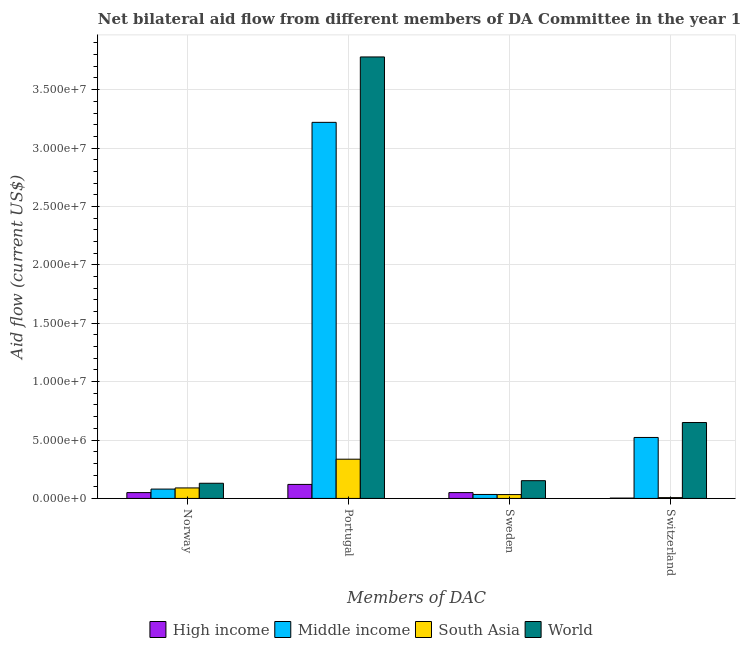How many different coloured bars are there?
Your answer should be very brief. 4. Are the number of bars per tick equal to the number of legend labels?
Your answer should be very brief. Yes. How many bars are there on the 3rd tick from the right?
Your response must be concise. 4. What is the amount of aid given by sweden in Middle income?
Offer a very short reply. 3.40e+05. Across all countries, what is the maximum amount of aid given by portugal?
Your answer should be compact. 3.78e+07. Across all countries, what is the minimum amount of aid given by switzerland?
Offer a terse response. 3.00e+04. In which country was the amount of aid given by sweden maximum?
Your response must be concise. World. What is the total amount of aid given by switzerland in the graph?
Your answer should be compact. 1.18e+07. What is the difference between the amount of aid given by norway in Middle income and that in World?
Keep it short and to the point. -5.00e+05. What is the difference between the amount of aid given by norway in High income and the amount of aid given by portugal in South Asia?
Your answer should be very brief. -2.86e+06. What is the average amount of aid given by sweden per country?
Offer a very short reply. 6.72e+05. What is the difference between the amount of aid given by portugal and amount of aid given by switzerland in World?
Offer a very short reply. 3.13e+07. What is the ratio of the amount of aid given by norway in Middle income to that in World?
Keep it short and to the point. 0.62. Is the amount of aid given by sweden in World less than that in Middle income?
Make the answer very short. No. Is the difference between the amount of aid given by portugal in South Asia and World greater than the difference between the amount of aid given by sweden in South Asia and World?
Offer a very short reply. No. What is the difference between the highest and the second highest amount of aid given by portugal?
Offer a terse response. 5.60e+06. What is the difference between the highest and the lowest amount of aid given by norway?
Offer a terse response. 8.00e+05. In how many countries, is the amount of aid given by sweden greater than the average amount of aid given by sweden taken over all countries?
Your answer should be compact. 1. Is it the case that in every country, the sum of the amount of aid given by norway and amount of aid given by sweden is greater than the sum of amount of aid given by switzerland and amount of aid given by portugal?
Provide a short and direct response. No. What does the 4th bar from the left in Norway represents?
Keep it short and to the point. World. Are the values on the major ticks of Y-axis written in scientific E-notation?
Keep it short and to the point. Yes. Does the graph contain grids?
Provide a succinct answer. Yes. Where does the legend appear in the graph?
Provide a short and direct response. Bottom center. How many legend labels are there?
Give a very brief answer. 4. What is the title of the graph?
Provide a short and direct response. Net bilateral aid flow from different members of DA Committee in the year 1961. What is the label or title of the X-axis?
Your answer should be very brief. Members of DAC. What is the Aid flow (current US$) of World in Norway?
Your answer should be very brief. 1.30e+06. What is the Aid flow (current US$) of High income in Portugal?
Provide a short and direct response. 1.20e+06. What is the Aid flow (current US$) in Middle income in Portugal?
Ensure brevity in your answer.  3.22e+07. What is the Aid flow (current US$) of South Asia in Portugal?
Your answer should be compact. 3.36e+06. What is the Aid flow (current US$) in World in Portugal?
Offer a terse response. 3.78e+07. What is the Aid flow (current US$) of Middle income in Sweden?
Provide a succinct answer. 3.40e+05. What is the Aid flow (current US$) of South Asia in Sweden?
Provide a succinct answer. 3.30e+05. What is the Aid flow (current US$) of World in Sweden?
Your answer should be very brief. 1.52e+06. What is the Aid flow (current US$) of Middle income in Switzerland?
Offer a terse response. 5.22e+06. What is the Aid flow (current US$) in World in Switzerland?
Your answer should be compact. 6.50e+06. Across all Members of DAC, what is the maximum Aid flow (current US$) of High income?
Ensure brevity in your answer.  1.20e+06. Across all Members of DAC, what is the maximum Aid flow (current US$) of Middle income?
Your answer should be compact. 3.22e+07. Across all Members of DAC, what is the maximum Aid flow (current US$) of South Asia?
Your response must be concise. 3.36e+06. Across all Members of DAC, what is the maximum Aid flow (current US$) in World?
Your answer should be very brief. 3.78e+07. Across all Members of DAC, what is the minimum Aid flow (current US$) in South Asia?
Your response must be concise. 7.00e+04. Across all Members of DAC, what is the minimum Aid flow (current US$) in World?
Provide a short and direct response. 1.30e+06. What is the total Aid flow (current US$) of High income in the graph?
Make the answer very short. 2.23e+06. What is the total Aid flow (current US$) of Middle income in the graph?
Your response must be concise. 3.86e+07. What is the total Aid flow (current US$) of South Asia in the graph?
Give a very brief answer. 4.66e+06. What is the total Aid flow (current US$) in World in the graph?
Provide a short and direct response. 4.71e+07. What is the difference between the Aid flow (current US$) in High income in Norway and that in Portugal?
Ensure brevity in your answer.  -7.00e+05. What is the difference between the Aid flow (current US$) of Middle income in Norway and that in Portugal?
Offer a terse response. -3.14e+07. What is the difference between the Aid flow (current US$) in South Asia in Norway and that in Portugal?
Your answer should be compact. -2.46e+06. What is the difference between the Aid flow (current US$) in World in Norway and that in Portugal?
Give a very brief answer. -3.65e+07. What is the difference between the Aid flow (current US$) of Middle income in Norway and that in Sweden?
Your answer should be compact. 4.60e+05. What is the difference between the Aid flow (current US$) in South Asia in Norway and that in Sweden?
Keep it short and to the point. 5.70e+05. What is the difference between the Aid flow (current US$) of World in Norway and that in Sweden?
Offer a terse response. -2.20e+05. What is the difference between the Aid flow (current US$) of High income in Norway and that in Switzerland?
Ensure brevity in your answer.  4.70e+05. What is the difference between the Aid flow (current US$) in Middle income in Norway and that in Switzerland?
Offer a terse response. -4.42e+06. What is the difference between the Aid flow (current US$) of South Asia in Norway and that in Switzerland?
Give a very brief answer. 8.30e+05. What is the difference between the Aid flow (current US$) of World in Norway and that in Switzerland?
Offer a terse response. -5.20e+06. What is the difference between the Aid flow (current US$) of Middle income in Portugal and that in Sweden?
Offer a terse response. 3.19e+07. What is the difference between the Aid flow (current US$) of South Asia in Portugal and that in Sweden?
Offer a terse response. 3.03e+06. What is the difference between the Aid flow (current US$) of World in Portugal and that in Sweden?
Your answer should be very brief. 3.63e+07. What is the difference between the Aid flow (current US$) of High income in Portugal and that in Switzerland?
Your response must be concise. 1.17e+06. What is the difference between the Aid flow (current US$) of Middle income in Portugal and that in Switzerland?
Your response must be concise. 2.70e+07. What is the difference between the Aid flow (current US$) in South Asia in Portugal and that in Switzerland?
Give a very brief answer. 3.29e+06. What is the difference between the Aid flow (current US$) of World in Portugal and that in Switzerland?
Offer a very short reply. 3.13e+07. What is the difference between the Aid flow (current US$) in High income in Sweden and that in Switzerland?
Offer a terse response. 4.70e+05. What is the difference between the Aid flow (current US$) of Middle income in Sweden and that in Switzerland?
Offer a very short reply. -4.88e+06. What is the difference between the Aid flow (current US$) in South Asia in Sweden and that in Switzerland?
Your response must be concise. 2.60e+05. What is the difference between the Aid flow (current US$) of World in Sweden and that in Switzerland?
Ensure brevity in your answer.  -4.98e+06. What is the difference between the Aid flow (current US$) in High income in Norway and the Aid flow (current US$) in Middle income in Portugal?
Make the answer very short. -3.17e+07. What is the difference between the Aid flow (current US$) of High income in Norway and the Aid flow (current US$) of South Asia in Portugal?
Offer a terse response. -2.86e+06. What is the difference between the Aid flow (current US$) in High income in Norway and the Aid flow (current US$) in World in Portugal?
Offer a terse response. -3.73e+07. What is the difference between the Aid flow (current US$) in Middle income in Norway and the Aid flow (current US$) in South Asia in Portugal?
Your answer should be compact. -2.56e+06. What is the difference between the Aid flow (current US$) of Middle income in Norway and the Aid flow (current US$) of World in Portugal?
Offer a terse response. -3.70e+07. What is the difference between the Aid flow (current US$) of South Asia in Norway and the Aid flow (current US$) of World in Portugal?
Ensure brevity in your answer.  -3.69e+07. What is the difference between the Aid flow (current US$) of High income in Norway and the Aid flow (current US$) of South Asia in Sweden?
Your answer should be very brief. 1.70e+05. What is the difference between the Aid flow (current US$) of High income in Norway and the Aid flow (current US$) of World in Sweden?
Offer a terse response. -1.02e+06. What is the difference between the Aid flow (current US$) of Middle income in Norway and the Aid flow (current US$) of World in Sweden?
Provide a succinct answer. -7.20e+05. What is the difference between the Aid flow (current US$) of South Asia in Norway and the Aid flow (current US$) of World in Sweden?
Keep it short and to the point. -6.20e+05. What is the difference between the Aid flow (current US$) in High income in Norway and the Aid flow (current US$) in Middle income in Switzerland?
Ensure brevity in your answer.  -4.72e+06. What is the difference between the Aid flow (current US$) in High income in Norway and the Aid flow (current US$) in South Asia in Switzerland?
Your answer should be very brief. 4.30e+05. What is the difference between the Aid flow (current US$) of High income in Norway and the Aid flow (current US$) of World in Switzerland?
Offer a terse response. -6.00e+06. What is the difference between the Aid flow (current US$) in Middle income in Norway and the Aid flow (current US$) in South Asia in Switzerland?
Provide a succinct answer. 7.30e+05. What is the difference between the Aid flow (current US$) in Middle income in Norway and the Aid flow (current US$) in World in Switzerland?
Give a very brief answer. -5.70e+06. What is the difference between the Aid flow (current US$) in South Asia in Norway and the Aid flow (current US$) in World in Switzerland?
Your response must be concise. -5.60e+06. What is the difference between the Aid flow (current US$) in High income in Portugal and the Aid flow (current US$) in Middle income in Sweden?
Make the answer very short. 8.60e+05. What is the difference between the Aid flow (current US$) in High income in Portugal and the Aid flow (current US$) in South Asia in Sweden?
Your answer should be very brief. 8.70e+05. What is the difference between the Aid flow (current US$) of High income in Portugal and the Aid flow (current US$) of World in Sweden?
Your answer should be very brief. -3.20e+05. What is the difference between the Aid flow (current US$) in Middle income in Portugal and the Aid flow (current US$) in South Asia in Sweden?
Ensure brevity in your answer.  3.19e+07. What is the difference between the Aid flow (current US$) of Middle income in Portugal and the Aid flow (current US$) of World in Sweden?
Give a very brief answer. 3.07e+07. What is the difference between the Aid flow (current US$) of South Asia in Portugal and the Aid flow (current US$) of World in Sweden?
Keep it short and to the point. 1.84e+06. What is the difference between the Aid flow (current US$) in High income in Portugal and the Aid flow (current US$) in Middle income in Switzerland?
Offer a very short reply. -4.02e+06. What is the difference between the Aid flow (current US$) of High income in Portugal and the Aid flow (current US$) of South Asia in Switzerland?
Your answer should be very brief. 1.13e+06. What is the difference between the Aid flow (current US$) in High income in Portugal and the Aid flow (current US$) in World in Switzerland?
Give a very brief answer. -5.30e+06. What is the difference between the Aid flow (current US$) of Middle income in Portugal and the Aid flow (current US$) of South Asia in Switzerland?
Give a very brief answer. 3.21e+07. What is the difference between the Aid flow (current US$) of Middle income in Portugal and the Aid flow (current US$) of World in Switzerland?
Provide a short and direct response. 2.57e+07. What is the difference between the Aid flow (current US$) of South Asia in Portugal and the Aid flow (current US$) of World in Switzerland?
Offer a terse response. -3.14e+06. What is the difference between the Aid flow (current US$) of High income in Sweden and the Aid flow (current US$) of Middle income in Switzerland?
Provide a succinct answer. -4.72e+06. What is the difference between the Aid flow (current US$) of High income in Sweden and the Aid flow (current US$) of South Asia in Switzerland?
Offer a very short reply. 4.30e+05. What is the difference between the Aid flow (current US$) in High income in Sweden and the Aid flow (current US$) in World in Switzerland?
Make the answer very short. -6.00e+06. What is the difference between the Aid flow (current US$) of Middle income in Sweden and the Aid flow (current US$) of South Asia in Switzerland?
Your answer should be compact. 2.70e+05. What is the difference between the Aid flow (current US$) of Middle income in Sweden and the Aid flow (current US$) of World in Switzerland?
Provide a succinct answer. -6.16e+06. What is the difference between the Aid flow (current US$) in South Asia in Sweden and the Aid flow (current US$) in World in Switzerland?
Make the answer very short. -6.17e+06. What is the average Aid flow (current US$) of High income per Members of DAC?
Ensure brevity in your answer.  5.58e+05. What is the average Aid flow (current US$) in Middle income per Members of DAC?
Keep it short and to the point. 9.64e+06. What is the average Aid flow (current US$) of South Asia per Members of DAC?
Make the answer very short. 1.16e+06. What is the average Aid flow (current US$) in World per Members of DAC?
Make the answer very short. 1.18e+07. What is the difference between the Aid flow (current US$) of High income and Aid flow (current US$) of Middle income in Norway?
Your response must be concise. -3.00e+05. What is the difference between the Aid flow (current US$) of High income and Aid flow (current US$) of South Asia in Norway?
Provide a short and direct response. -4.00e+05. What is the difference between the Aid flow (current US$) in High income and Aid flow (current US$) in World in Norway?
Provide a succinct answer. -8.00e+05. What is the difference between the Aid flow (current US$) of Middle income and Aid flow (current US$) of World in Norway?
Make the answer very short. -5.00e+05. What is the difference between the Aid flow (current US$) in South Asia and Aid flow (current US$) in World in Norway?
Provide a succinct answer. -4.00e+05. What is the difference between the Aid flow (current US$) in High income and Aid flow (current US$) in Middle income in Portugal?
Your answer should be compact. -3.10e+07. What is the difference between the Aid flow (current US$) of High income and Aid flow (current US$) of South Asia in Portugal?
Your response must be concise. -2.16e+06. What is the difference between the Aid flow (current US$) of High income and Aid flow (current US$) of World in Portugal?
Offer a very short reply. -3.66e+07. What is the difference between the Aid flow (current US$) of Middle income and Aid flow (current US$) of South Asia in Portugal?
Provide a succinct answer. 2.88e+07. What is the difference between the Aid flow (current US$) in Middle income and Aid flow (current US$) in World in Portugal?
Offer a very short reply. -5.60e+06. What is the difference between the Aid flow (current US$) of South Asia and Aid flow (current US$) of World in Portugal?
Provide a short and direct response. -3.44e+07. What is the difference between the Aid flow (current US$) in High income and Aid flow (current US$) in Middle income in Sweden?
Ensure brevity in your answer.  1.60e+05. What is the difference between the Aid flow (current US$) of High income and Aid flow (current US$) of World in Sweden?
Give a very brief answer. -1.02e+06. What is the difference between the Aid flow (current US$) of Middle income and Aid flow (current US$) of World in Sweden?
Provide a short and direct response. -1.18e+06. What is the difference between the Aid flow (current US$) of South Asia and Aid flow (current US$) of World in Sweden?
Give a very brief answer. -1.19e+06. What is the difference between the Aid flow (current US$) in High income and Aid flow (current US$) in Middle income in Switzerland?
Make the answer very short. -5.19e+06. What is the difference between the Aid flow (current US$) of High income and Aid flow (current US$) of South Asia in Switzerland?
Give a very brief answer. -4.00e+04. What is the difference between the Aid flow (current US$) of High income and Aid flow (current US$) of World in Switzerland?
Your answer should be compact. -6.47e+06. What is the difference between the Aid flow (current US$) in Middle income and Aid flow (current US$) in South Asia in Switzerland?
Ensure brevity in your answer.  5.15e+06. What is the difference between the Aid flow (current US$) of Middle income and Aid flow (current US$) of World in Switzerland?
Make the answer very short. -1.28e+06. What is the difference between the Aid flow (current US$) in South Asia and Aid flow (current US$) in World in Switzerland?
Provide a succinct answer. -6.43e+06. What is the ratio of the Aid flow (current US$) in High income in Norway to that in Portugal?
Provide a succinct answer. 0.42. What is the ratio of the Aid flow (current US$) of Middle income in Norway to that in Portugal?
Your response must be concise. 0.02. What is the ratio of the Aid flow (current US$) in South Asia in Norway to that in Portugal?
Keep it short and to the point. 0.27. What is the ratio of the Aid flow (current US$) in World in Norway to that in Portugal?
Your response must be concise. 0.03. What is the ratio of the Aid flow (current US$) in Middle income in Norway to that in Sweden?
Keep it short and to the point. 2.35. What is the ratio of the Aid flow (current US$) of South Asia in Norway to that in Sweden?
Ensure brevity in your answer.  2.73. What is the ratio of the Aid flow (current US$) in World in Norway to that in Sweden?
Ensure brevity in your answer.  0.86. What is the ratio of the Aid flow (current US$) in High income in Norway to that in Switzerland?
Ensure brevity in your answer.  16.67. What is the ratio of the Aid flow (current US$) in Middle income in Norway to that in Switzerland?
Offer a very short reply. 0.15. What is the ratio of the Aid flow (current US$) of South Asia in Norway to that in Switzerland?
Offer a terse response. 12.86. What is the ratio of the Aid flow (current US$) in World in Norway to that in Switzerland?
Your answer should be compact. 0.2. What is the ratio of the Aid flow (current US$) in High income in Portugal to that in Sweden?
Make the answer very short. 2.4. What is the ratio of the Aid flow (current US$) in Middle income in Portugal to that in Sweden?
Ensure brevity in your answer.  94.71. What is the ratio of the Aid flow (current US$) of South Asia in Portugal to that in Sweden?
Your answer should be compact. 10.18. What is the ratio of the Aid flow (current US$) in World in Portugal to that in Sweden?
Your answer should be very brief. 24.87. What is the ratio of the Aid flow (current US$) in High income in Portugal to that in Switzerland?
Keep it short and to the point. 40. What is the ratio of the Aid flow (current US$) in Middle income in Portugal to that in Switzerland?
Give a very brief answer. 6.17. What is the ratio of the Aid flow (current US$) in World in Portugal to that in Switzerland?
Provide a succinct answer. 5.82. What is the ratio of the Aid flow (current US$) in High income in Sweden to that in Switzerland?
Your response must be concise. 16.67. What is the ratio of the Aid flow (current US$) in Middle income in Sweden to that in Switzerland?
Your answer should be very brief. 0.07. What is the ratio of the Aid flow (current US$) of South Asia in Sweden to that in Switzerland?
Ensure brevity in your answer.  4.71. What is the ratio of the Aid flow (current US$) in World in Sweden to that in Switzerland?
Offer a terse response. 0.23. What is the difference between the highest and the second highest Aid flow (current US$) of High income?
Make the answer very short. 7.00e+05. What is the difference between the highest and the second highest Aid flow (current US$) of Middle income?
Provide a short and direct response. 2.70e+07. What is the difference between the highest and the second highest Aid flow (current US$) in South Asia?
Ensure brevity in your answer.  2.46e+06. What is the difference between the highest and the second highest Aid flow (current US$) of World?
Offer a very short reply. 3.13e+07. What is the difference between the highest and the lowest Aid flow (current US$) in High income?
Your answer should be very brief. 1.17e+06. What is the difference between the highest and the lowest Aid flow (current US$) in Middle income?
Provide a succinct answer. 3.19e+07. What is the difference between the highest and the lowest Aid flow (current US$) of South Asia?
Give a very brief answer. 3.29e+06. What is the difference between the highest and the lowest Aid flow (current US$) of World?
Make the answer very short. 3.65e+07. 